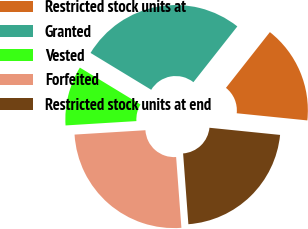Convert chart. <chart><loc_0><loc_0><loc_500><loc_500><pie_chart><fcel>Restricted stock units at<fcel>Granted<fcel>Vested<fcel>Forfeited<fcel>Restricted stock units at end<nl><fcel>15.99%<fcel>26.93%<fcel>9.67%<fcel>25.21%<fcel>22.21%<nl></chart> 